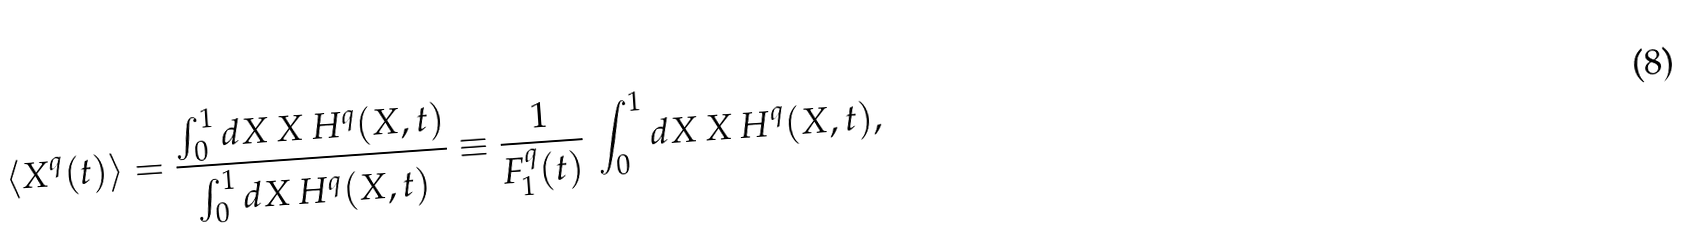Convert formula to latex. <formula><loc_0><loc_0><loc_500><loc_500>\langle X ^ { q } ( t ) \rangle = \frac { \int _ { 0 } ^ { 1 } d X \, X \, H ^ { q } ( X , t ) } { \int _ { 0 } ^ { 1 } d X \, H ^ { q } ( X , t ) } \equiv \frac { 1 } { F _ { 1 } ^ { q } ( t ) } \, \int _ { 0 } ^ { 1 } d X \, X \, H ^ { q } ( X , t ) ,</formula> 